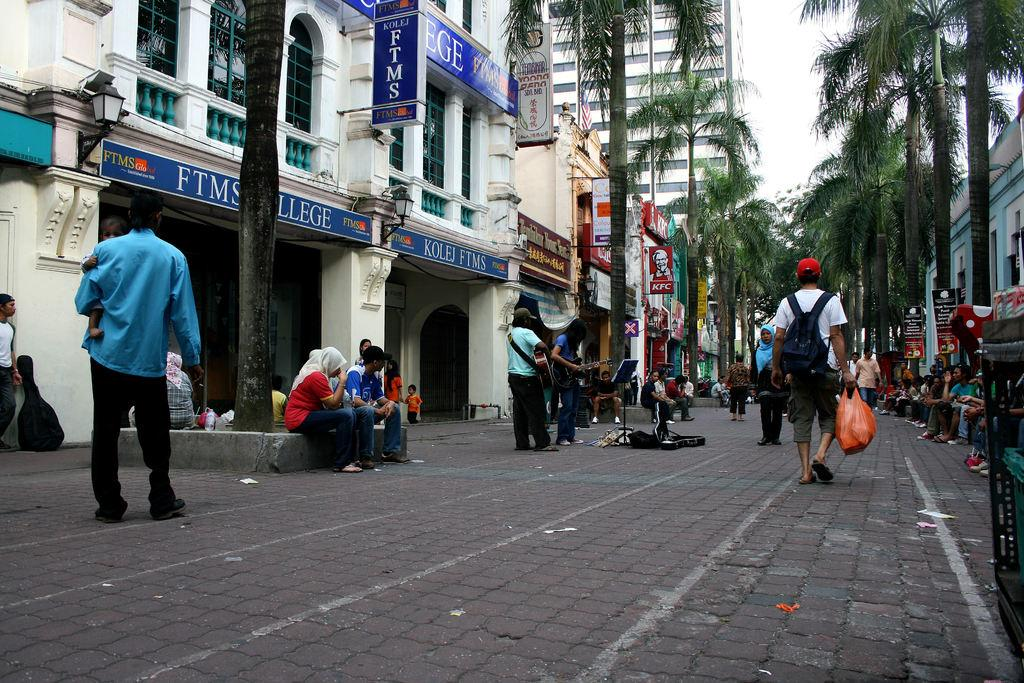What are the people in the image doing? There are people sitting and walking in the image. What type of natural elements can be seen in the image? A: There are trees in the image. What type of man-made structures are present in the image? There are buildings in the image. What part of the natural environment is visible in the image? The sky is visible in the image. What type of lunchroom can be seen in the image? There is no lunchroom present in the image. What subject is being taught in the image? There is no teaching activity depicted in the image. 